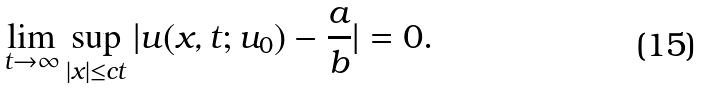<formula> <loc_0><loc_0><loc_500><loc_500>\lim _ { t \to \infty } \sup _ { | x | \leq c t } | u ( x , t ; u _ { 0 } ) - \frac { a } { b } | = 0 .</formula> 